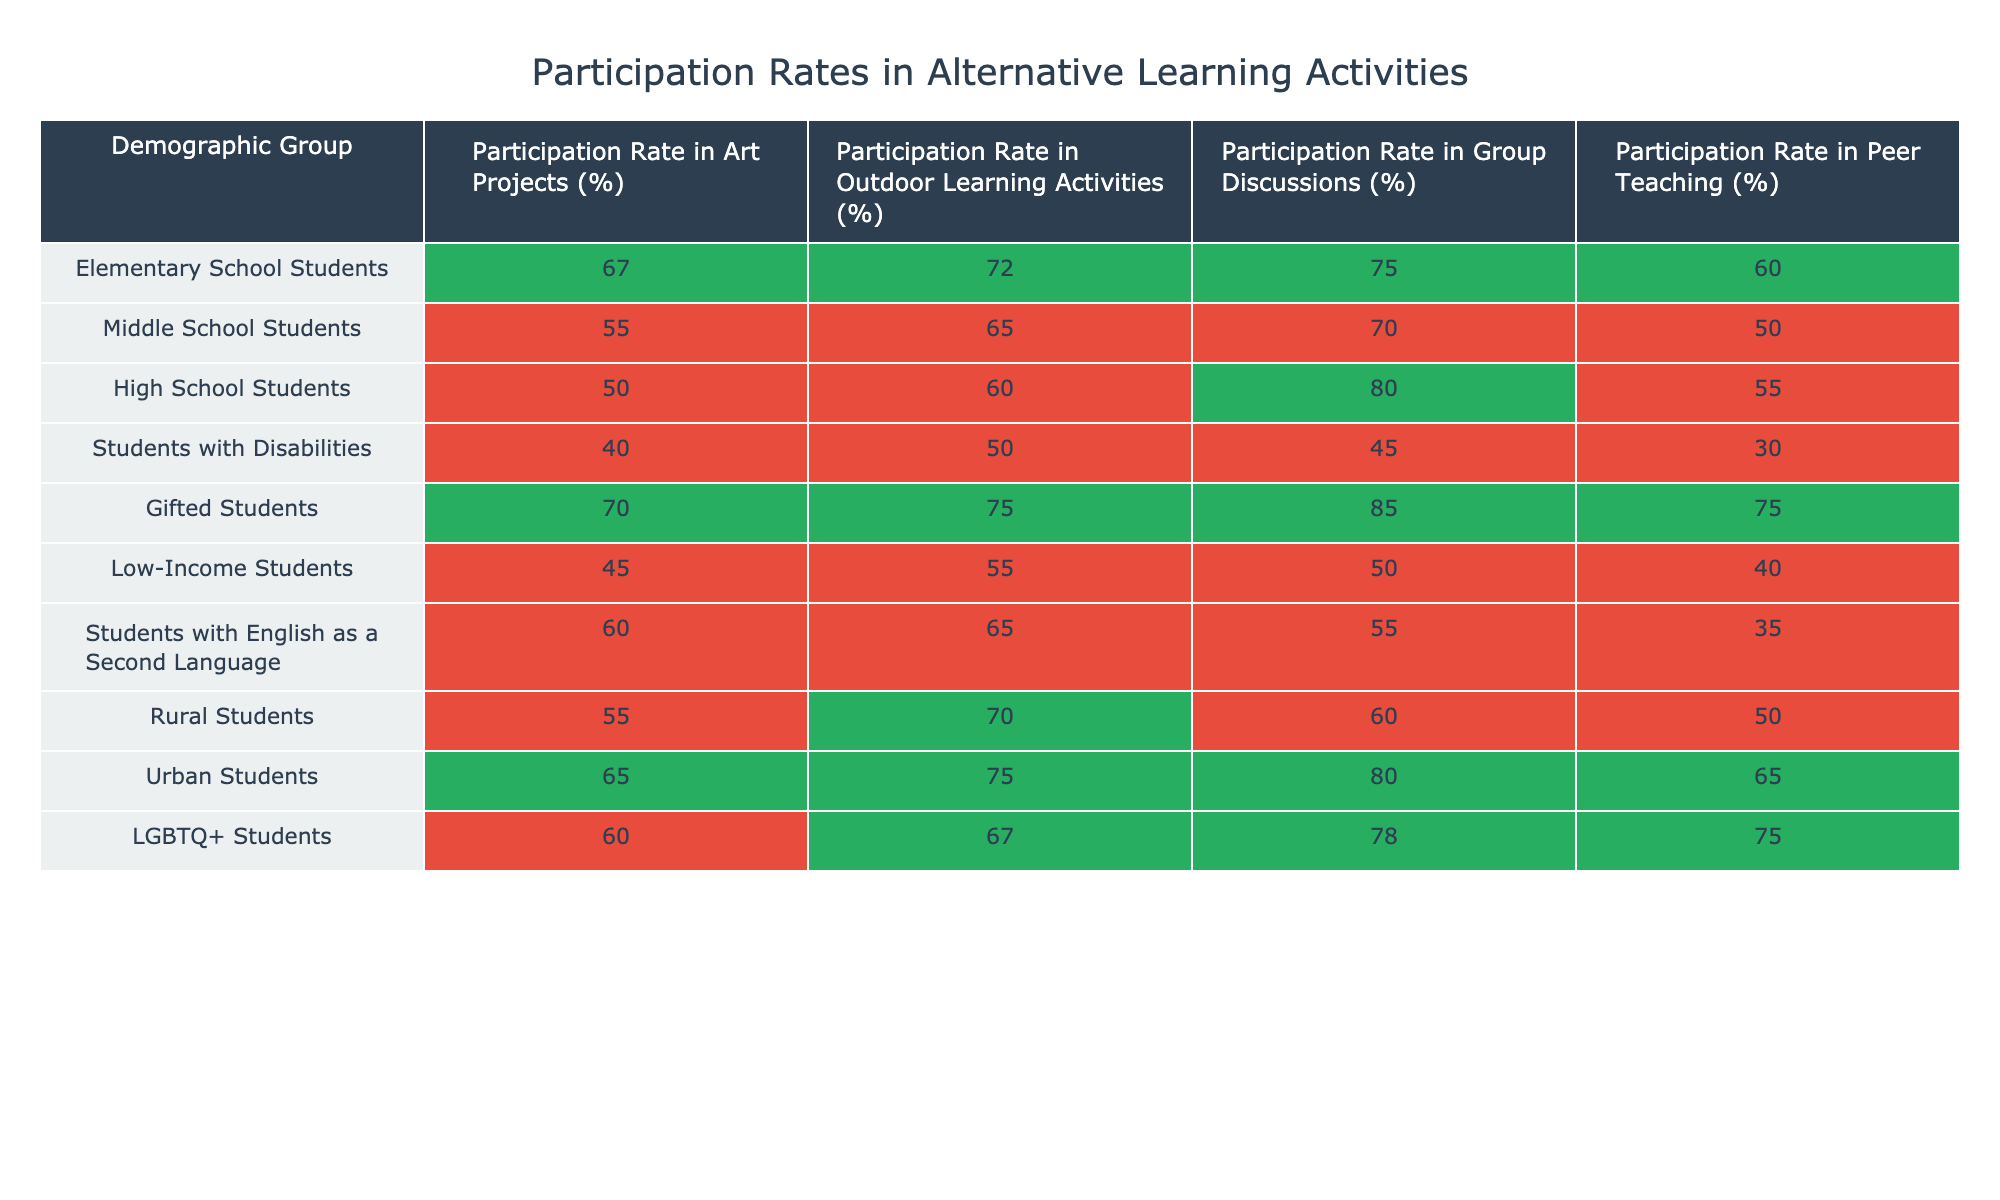What is the participation rate in art projects for gifted students? The table shows the participation rate in art projects for gifted students, which is listed directly in the column for "Participation Rate in Art Projects (%)". It reads 70%.
Answer: 70% Which demographic group has the lowest participation rate in peer teaching? In the table, the participation rates in peer teaching are compared across all demographic groups. Students with disabilities have the lowest rate at 30%.
Answer: 30% What is the average participation rate in outdoor learning activities for rural and low-income students combined? To find the average, first add the participation rates: Rural Students = 70% and Low-Income Students = 55%. Therefore, 70 + 55 = 125%. Then, divide by the number of groups (2): 125 / 2 = 62.5%.
Answer: 62.5% Is the participation rate in group discussions for middle school students greater than for students with disabilities? Looking at the table, the rate for middle school students is 70%, while for students with disabilities it is 45%. Since 70% is greater than 45%, the answer is yes.
Answer: Yes Which demographic group shows the highest participation rate in group discussions, and what is that percentage? By scanning the column for "Participation Rate in Group Discussions (%)", the highest rate is 85%, which belongs to gifted students.
Answer: Gifted Students, 85% What is the difference in participation rates for outdoor learning activities between urban students and students with disabilities? The participation rate for urban students is 75% and for students with disabilities, it is 50%. To find the difference, subtract: 75 - 50 = 25%.
Answer: 25% Is it true that all student demographics have a participation rate of at least 50% in group discussions? By checking the values listed under "Participation Rate in Group Discussions (%)", students with disabilities have a rate of 45%, which is below 50%. Therefore, the statement is false.
Answer: No What is the median participation rate in art projects across all listed demographic groups? Listing the participation rates in art projects gives: 40%, 45%, 50%, 55%, 60%, 67%, 70%, 67%, 70%, 85%. To find the median, arrange them in ascending order, and find the middle values, which in this case would be between 60% and 67%, averaging to 63.5%.
Answer: 63.5% 